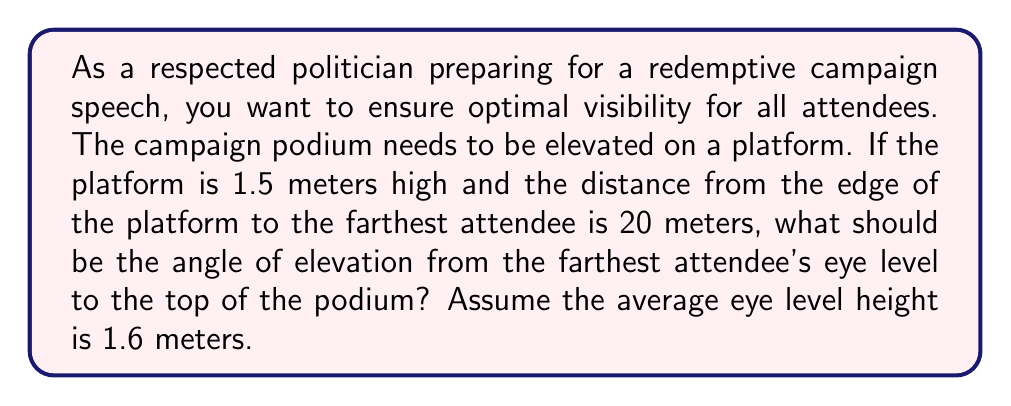Could you help me with this problem? To solve this problem, we need to use trigonometry, specifically the tangent function. Let's break it down step by step:

1. Visualize the scenario:
   [asy]
   import geometry;
   
   size(200);
   
   pair A = (0,0);
   pair B = (20,0);
   pair C = (0,1.5);
   pair D = (0,1.6);
   
   draw(A--B--C--A);
   draw(B--D,dashed);
   
   label("1.5m", A--C, W);
   label("20m", A--B, S);
   label("1.6m", B--D, E);
   label("θ", B, NE);
   
   draw(arc(B,0.5,0,atan2(1.5-1.6,20)*180/pi), Arrow);
   [/asy]

2. Identify the known values:
   - Height of the platform: 1.5 meters
   - Distance to the farthest attendee: 20 meters
   - Average eye level height: 1.6 meters

3. Calculate the height difference between the top of the podium and the attendee's eye level:
   $\text{Height difference} = 1.5 - 1.6 = -0.1$ meters

4. Use the tangent function to find the angle of elevation:
   $\tan(\theta) = \frac{\text{opposite}}{\text{adjacent}} = \frac{\text{height difference}}{\text{distance}}$

5. Substitute the values:
   $\tan(\theta) = \frac{-0.1}{20}$

6. To find θ, we need to use the inverse tangent (arctan or $\tan^{-1}$):
   $\theta = \tan^{-1}(\frac{-0.1}{20})$

7. Calculate the result:
   $\theta = \tan^{-1}(-0.005) \approx -0.2865$ radians

8. Convert radians to degrees:
   $\theta \approx -0.2865 \times \frac{180^{\circ}}{\pi} \approx -16.41^{\circ}$

The negative angle indicates that the attendee will be looking slightly downward to the podium.
Answer: The angle of elevation is approximately $-0.2865$ radians or $-16.41^{\circ}$. 